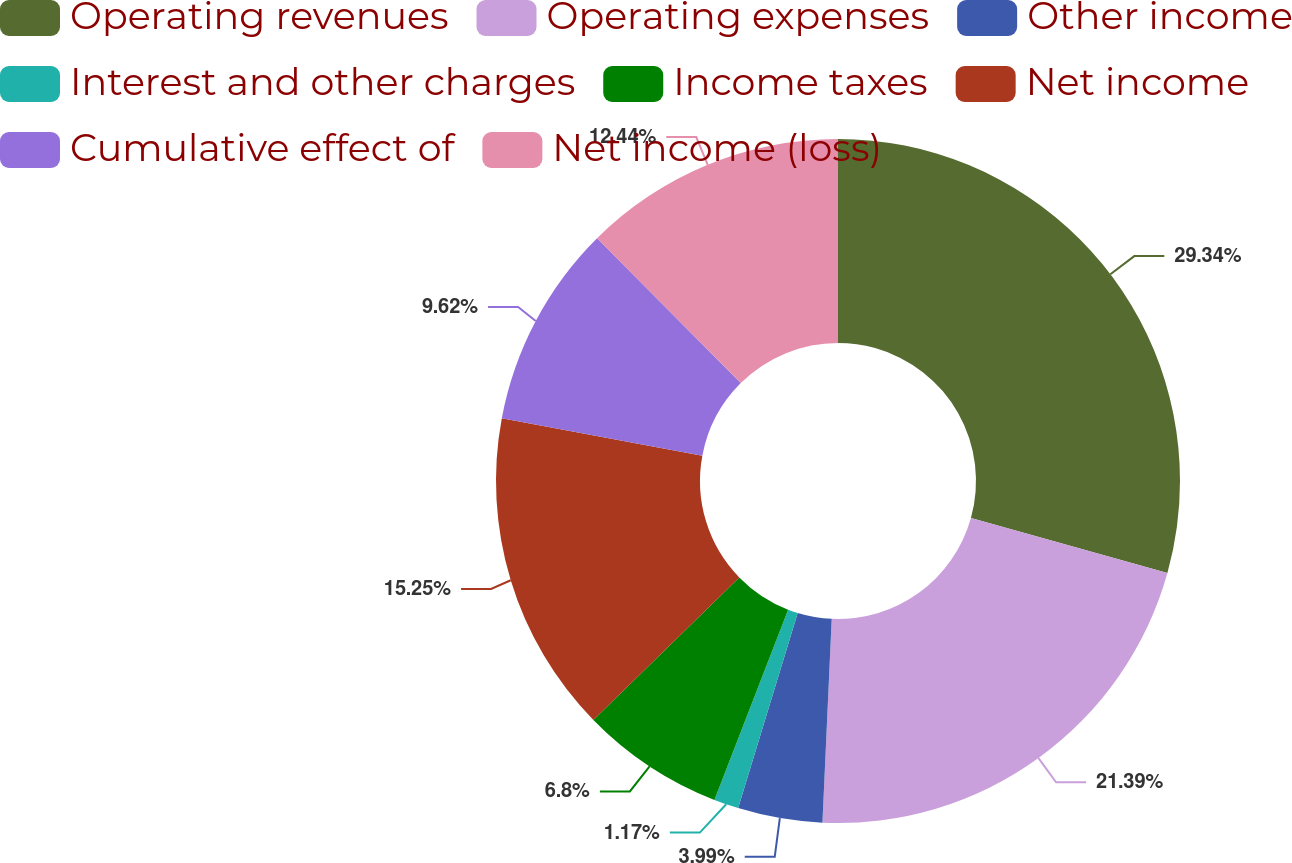Convert chart. <chart><loc_0><loc_0><loc_500><loc_500><pie_chart><fcel>Operating revenues<fcel>Operating expenses<fcel>Other income<fcel>Interest and other charges<fcel>Income taxes<fcel>Net income<fcel>Cumulative effect of<fcel>Net income (loss)<nl><fcel>29.33%<fcel>21.39%<fcel>3.99%<fcel>1.17%<fcel>6.8%<fcel>15.25%<fcel>9.62%<fcel>12.44%<nl></chart> 